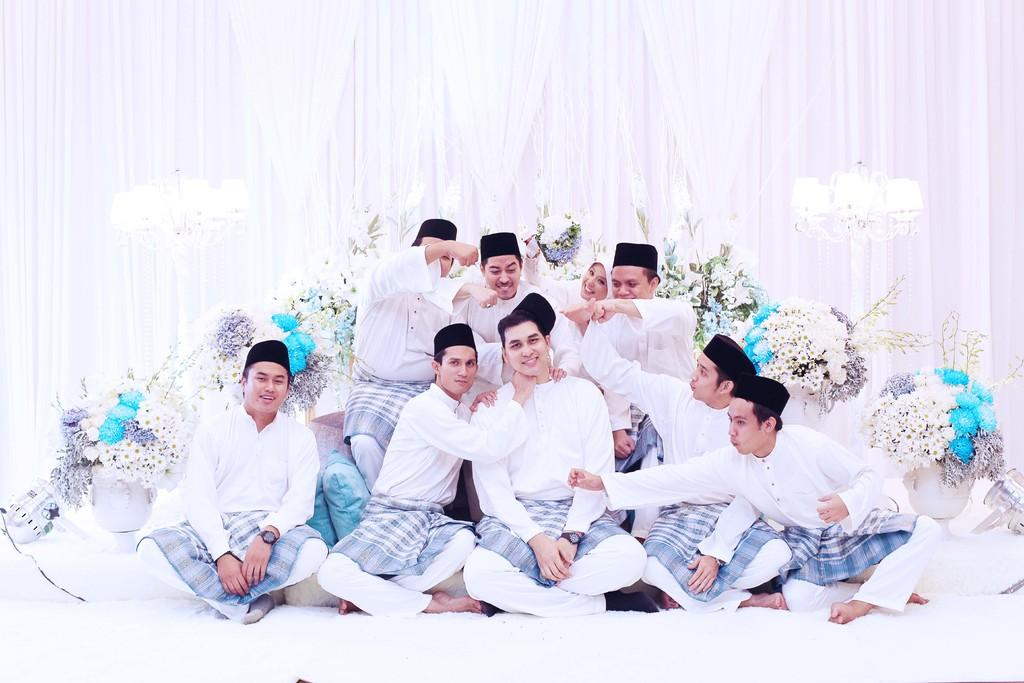What are the people in the image doing? The people in the image are sitting on the floor and on a sofa. What can be seen behind the people? There are flower pots and lamps behind the people. Are there any window treatments visible in the image? Yes, there are curtains associated with the lamps or windows. How many cows are present in the image? There are no cows present in the image. What type of badge is being worn by the people in the image? There is no badge visible in the image. 